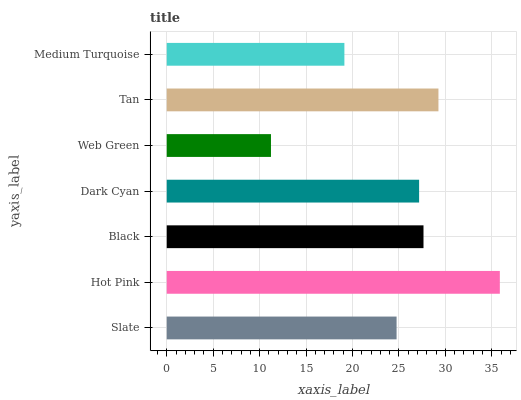Is Web Green the minimum?
Answer yes or no. Yes. Is Hot Pink the maximum?
Answer yes or no. Yes. Is Black the minimum?
Answer yes or no. No. Is Black the maximum?
Answer yes or no. No. Is Hot Pink greater than Black?
Answer yes or no. Yes. Is Black less than Hot Pink?
Answer yes or no. Yes. Is Black greater than Hot Pink?
Answer yes or no. No. Is Hot Pink less than Black?
Answer yes or no. No. Is Dark Cyan the high median?
Answer yes or no. Yes. Is Dark Cyan the low median?
Answer yes or no. Yes. Is Hot Pink the high median?
Answer yes or no. No. Is Tan the low median?
Answer yes or no. No. 